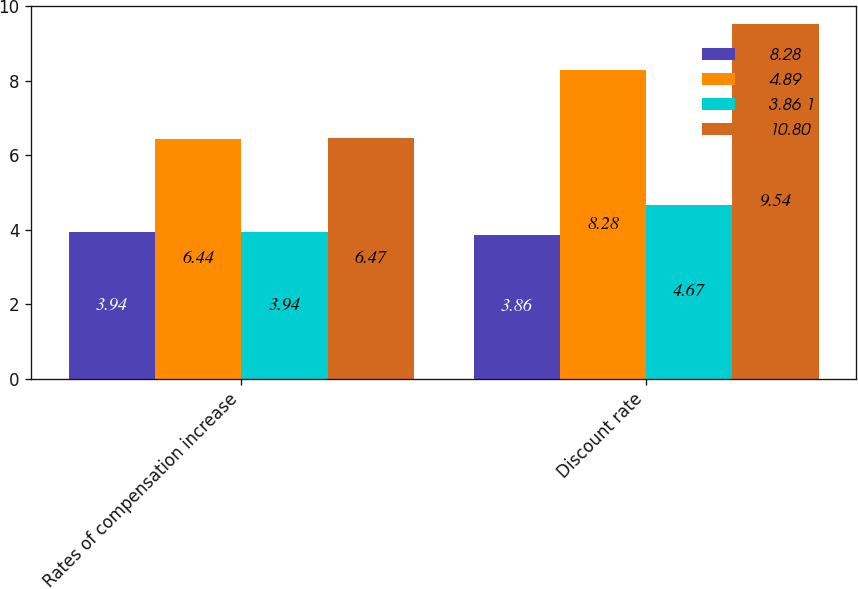Convert chart to OTSL. <chart><loc_0><loc_0><loc_500><loc_500><stacked_bar_chart><ecel><fcel>Rates of compensation increase<fcel>Discount rate<nl><fcel>8.28<fcel>3.94<fcel>3.86<nl><fcel>4.89<fcel>6.44<fcel>8.28<nl><fcel>3.86 1<fcel>3.94<fcel>4.67<nl><fcel>10.80<fcel>6.47<fcel>9.54<nl></chart> 